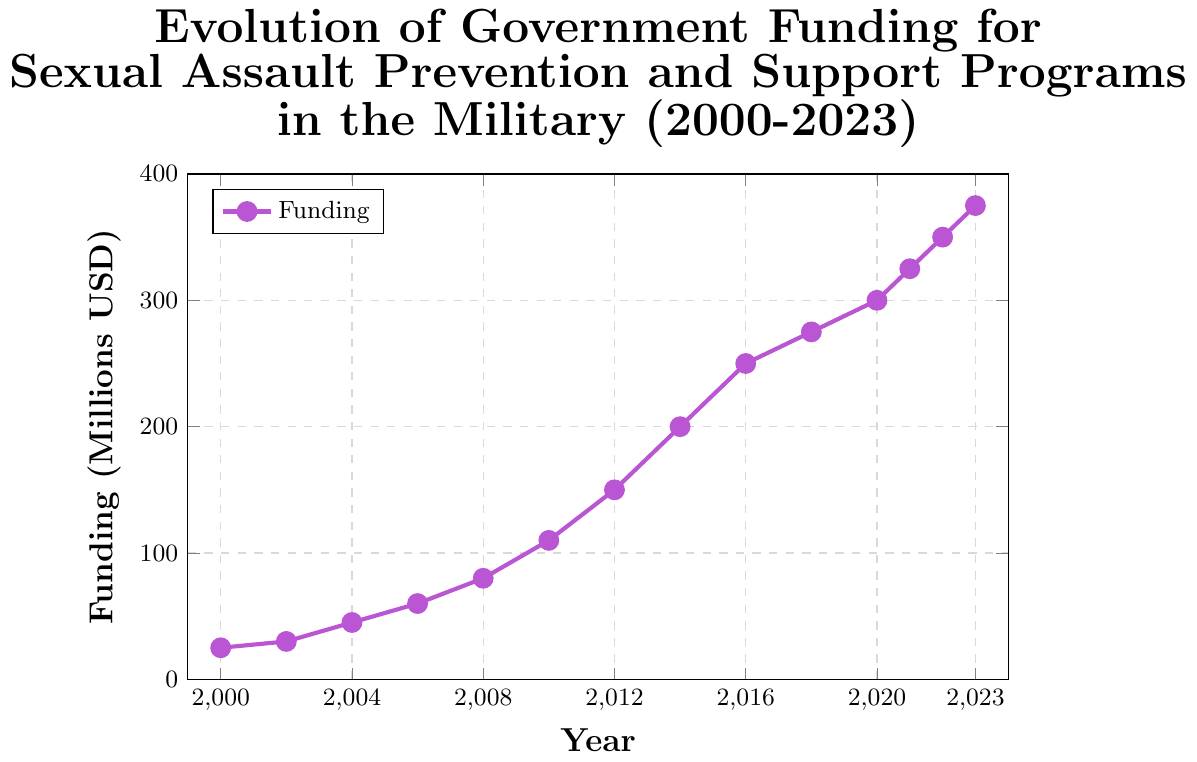What was the amount of government funding for sexual assault prevention and support programs in the military in the year 2010? Look at the data point for the year 2010; it corresponds to the amount 110 million USD
Answer: 110 million USD What was the increase in funding from 2000 to 2008? Subtract the funding amount in 2000 (25 million USD) from the amount in 2008 (80 million USD): 80 - 25 = 55 million USD
Answer: 55 million USD How much did the funding increase between 2020 and 2023? Subtract the funding amount in 2020 (300 million USD) from the amount in 2023 (375 million USD): 375 - 300 = 75 million USD
Answer: 75 million USD Which year between 2000 and 2023 saw the highest increase in funding compared to the previous data point? Compare the year-over-year increases:
- 2002: 30 - 25 = 5 million USD
- 2004: 45 - 30 = 15 million USD
- 2006: 60 - 45 = 15 million USD
- 2008: 80 - 60 = 20 million USD
- 2010: 110 - 80 = 30 million USD
- 2012: 150 - 110 = 40 million USD
- 2014: 200 - 150 = 50 million USD
- 2016: 250 - 200 = 50 million USD
- 2018: 275 - 250 = 25 million USD
- 2020: 300 - 275 = 25 million USD
- 2021: 325 - 300 = 25 million USD
- 2022: 350 - 325 = 25 million USD
- 2023: 375 - 350 = 25 million USD
The highest increases occurred from 2012 to 2014 and 2014 to 2016, both with 50 million USD increases
Answer: 2014 and 2016 In which year did the funding first exceed 100 million USD? Locate the year when the funding amount surpasses 100 million USD for the first time; it occurs in 2010 with 110 million USD
Answer: 2010 What is the average annual funding over the entire period from 2000 to 2023? Add all the funding values and divide by the number of years (14 data points):
(25 + 30 + 45 + 60 + 80 + 110 + 150 + 200 + 250 + 275 + 300 + 325 + 350 + 375) / 14 = 2575 / 14 = 183.93 (approximately)
Answer: 183.93 million USD By how much did the funding increase on average per year between 2000 and 2023? Subtract the initial funding in 2000 from the final funding in 2023 and divide by the number of years:
(375 - 25) / (2023 - 2000) = 350 / 23 = 15.22 (approximately)
Answer: 15.22 million USD 